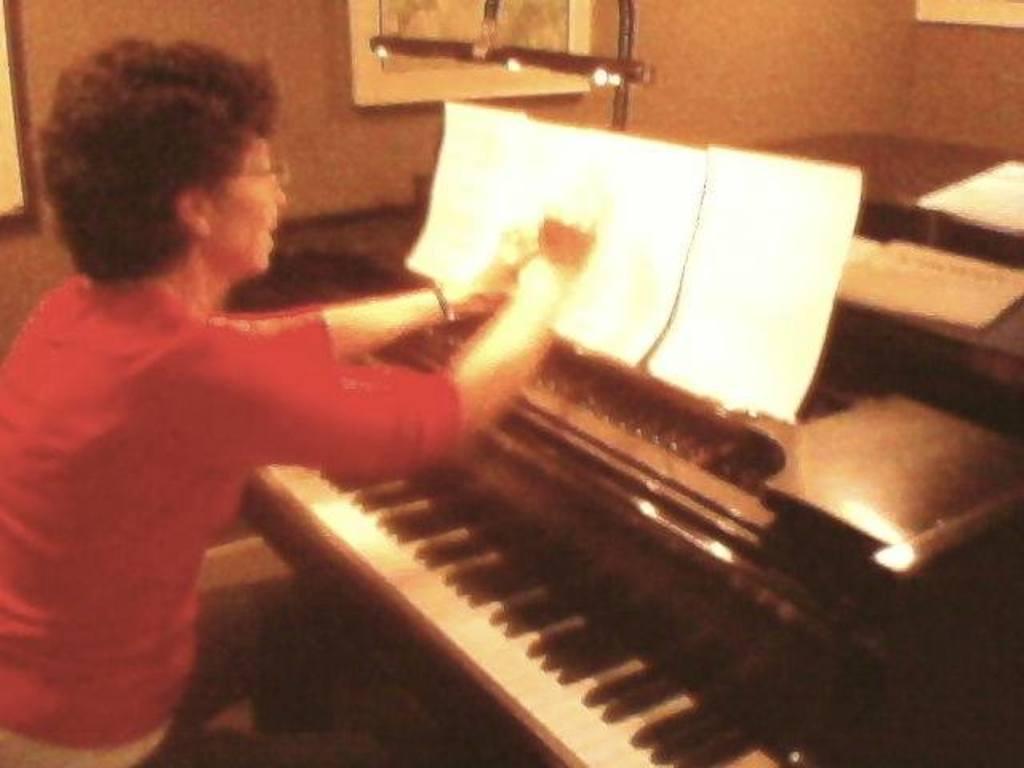Could you give a brief overview of what you see in this image? In this picture we can see a woman. These are the papers and this is piano. 